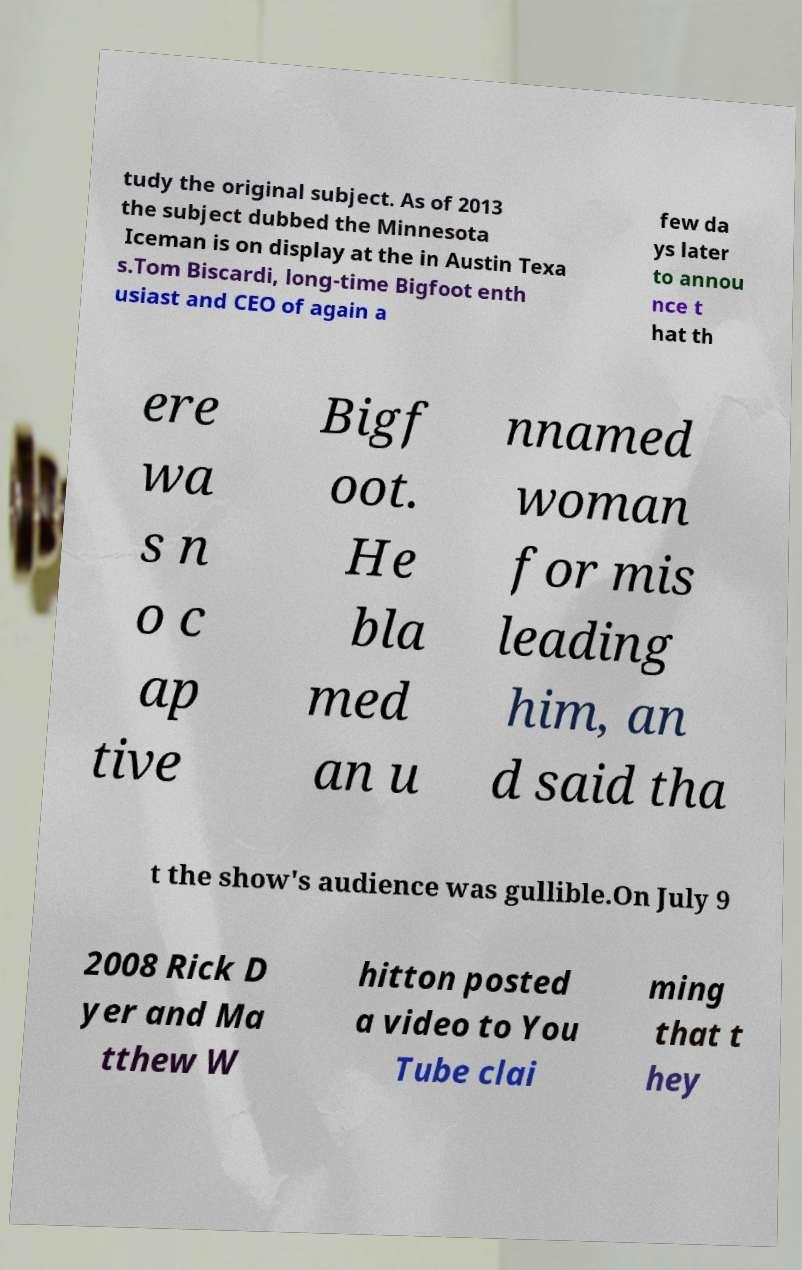Could you extract and type out the text from this image? tudy the original subject. As of 2013 the subject dubbed the Minnesota Iceman is on display at the in Austin Texa s.Tom Biscardi, long-time Bigfoot enth usiast and CEO of again a few da ys later to annou nce t hat th ere wa s n o c ap tive Bigf oot. He bla med an u nnamed woman for mis leading him, an d said tha t the show's audience was gullible.On July 9 2008 Rick D yer and Ma tthew W hitton posted a video to You Tube clai ming that t hey 